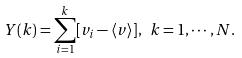Convert formula to latex. <formula><loc_0><loc_0><loc_500><loc_500>Y ( k ) = \sum _ { i = 1 } ^ { k } [ v _ { i } - \langle v \rangle ] , \ k = 1 , \cdots , N .</formula> 